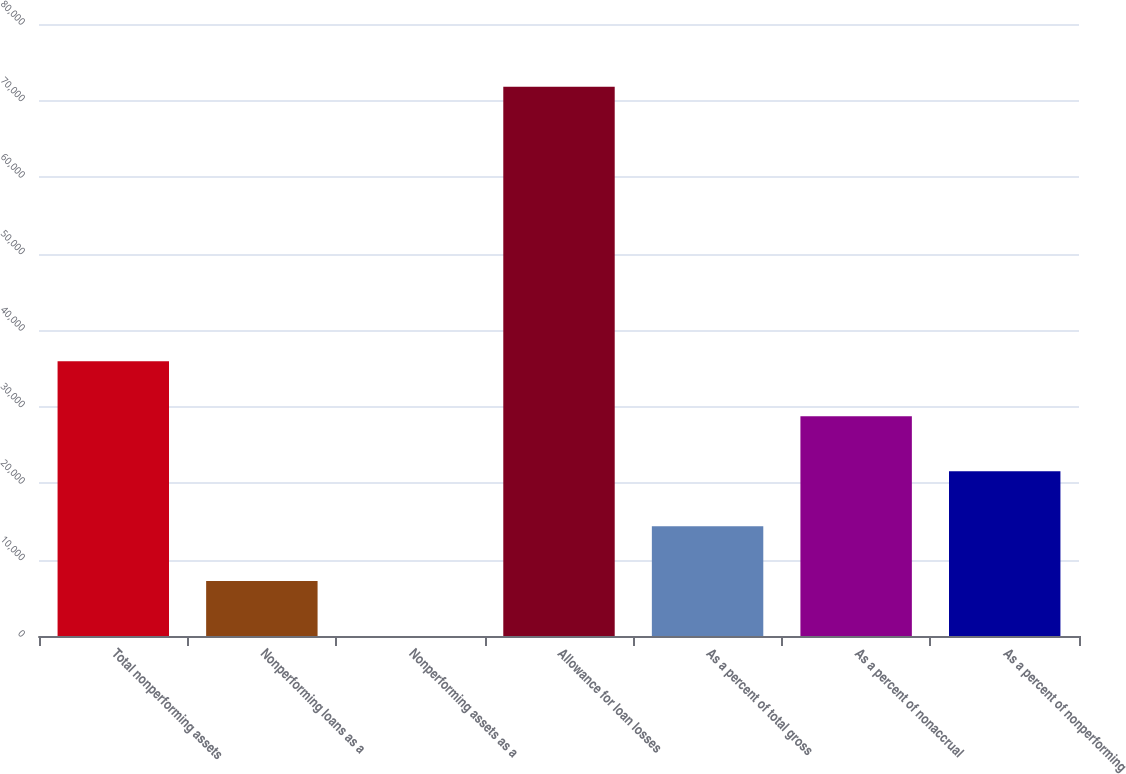<chart> <loc_0><loc_0><loc_500><loc_500><bar_chart><fcel>Total nonperforming assets<fcel>Nonperforming loans as a<fcel>Nonperforming assets as a<fcel>Allowance for loan losses<fcel>As a percent of total gross<fcel>As a percent of nonaccrual<fcel>As a percent of nonperforming<nl><fcel>35900.3<fcel>7180.54<fcel>0.6<fcel>71800<fcel>14360.5<fcel>28720.4<fcel>21540.4<nl></chart> 